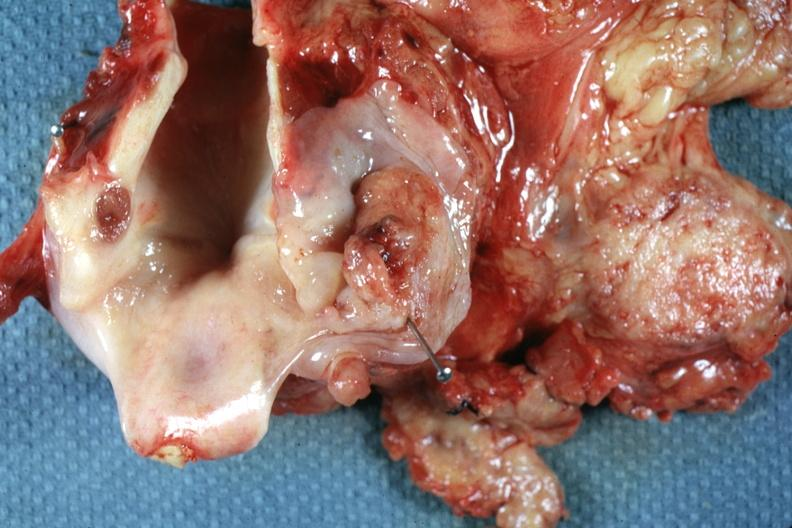s squamous cell carcinoma present?
Answer the question using a single word or phrase. Yes 